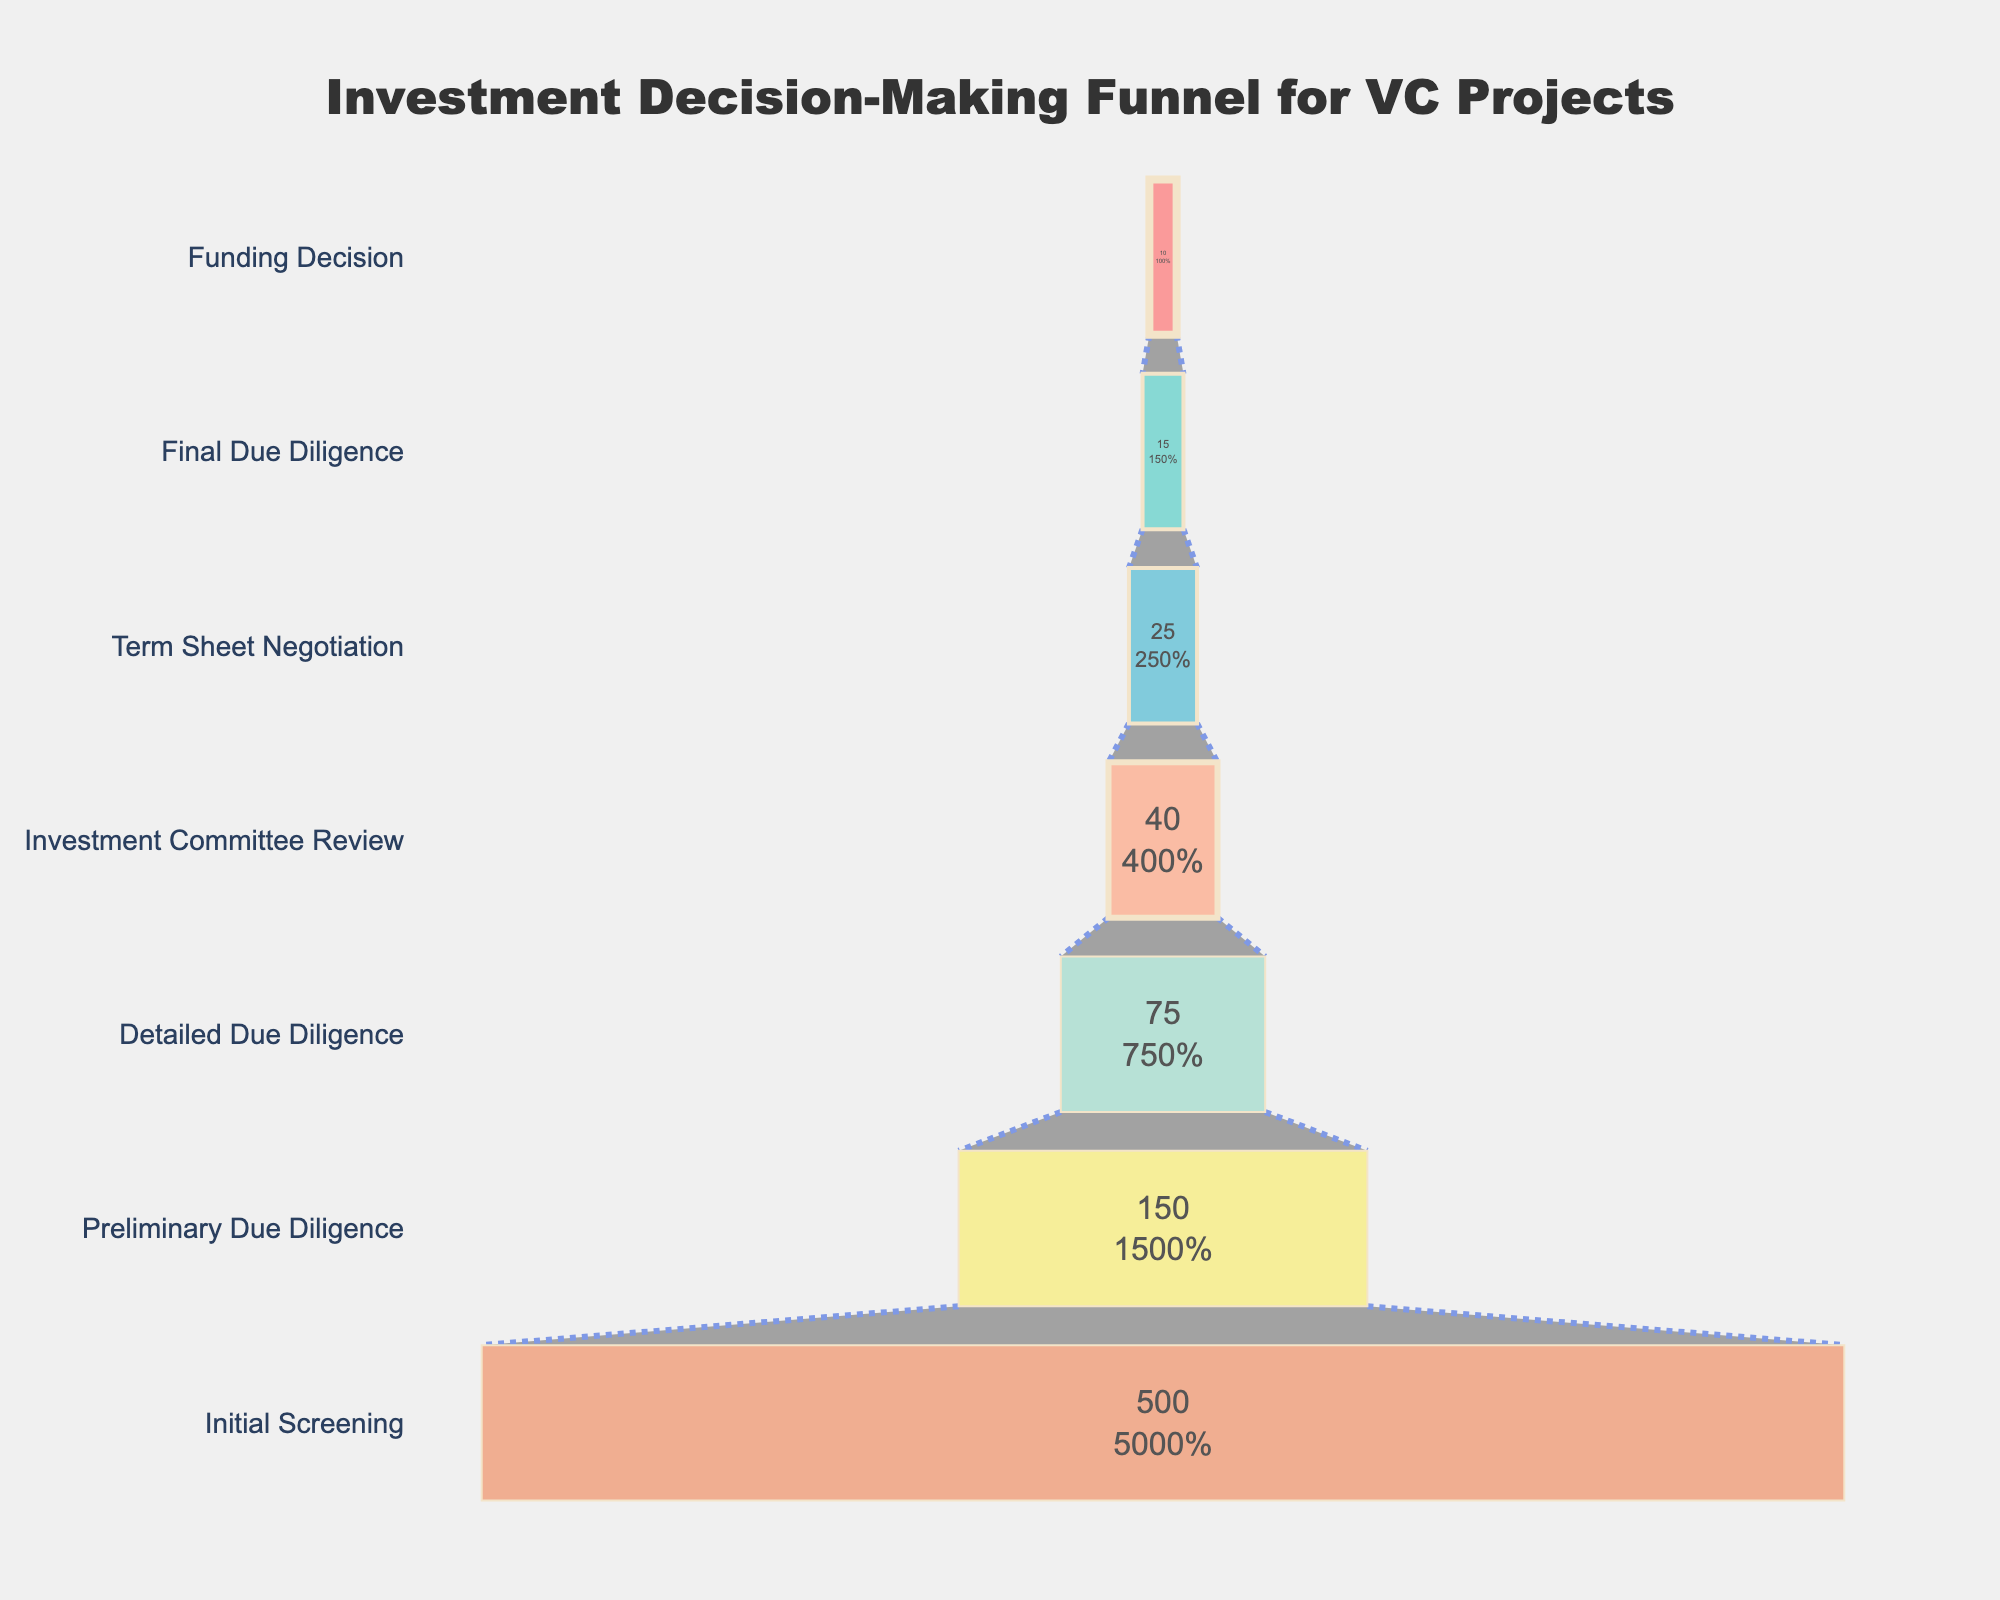What is the title of the funnel chart? The title is generally located at the top of the chart. In this case, it reads "Investment Decision-Making Funnel for VC Projects".
Answer: Investment Decision-Making Funnel for VC Projects How many projects made it to the Final Due Diligence stage? Look at the section labeled "Final Due Diligence"; the associated value is 15.
Answer: 15 What percentage of projects from the Initial Screening passed to the Preliminary Due Diligence stage? The chart shows 150 out of the 500 initial projects progressed to Preliminary Due Diligence. The percentage is calculated as (150/500) * 100.
Answer: 30% What is the difference in the number of projects between the Preliminary Due Diligence and Investment Committee Review stages? The value for Preliminary Due Diligence is 150 and for Investment Committee Review is 40. Subtract 40 from 150.
Answer: 110 Which stage has the fewest projects? Look for the stage with the smallest number; this is "Funding Decision" with 10 projects.
Answer: Funding Decision Between which two stages is the greatest reduction in the number of projects observed? Compare the reduction between consecutive stages. The largest drop is from Initial Screening to Preliminary Due Diligence (from 500 to 150), which is a reduction of 350 projects.
Answer: Initial Screening to Preliminary Due Diligence What is the average number of projects across all stages? Sum the number of projects at all stages and divide by the number of stages. The sum is (500 + 150 + 75 + 40 + 25 + 15 + 10) = 815, and there are 7 stages. The average is 815/7.
Answer: 116.43 How many stages are displayed in the funnel chart? Count the number of distinct stages listed on the y-axis of the funnel chart.
Answer: 7 Explain the color coding used in the funnel chart. Colors differentiate between stages. Each stage has a unique color which helps visually distinguish each part of the funnel. For instance, Initial Screening is colored in red (#FF6B6B), Preliminary Due Diligence in green (#4ECDC4), and so forth.
Answer: Each stage has a unique color If the number of projects in Term Sheet Negotiation doubled, how many would there be? The current number of projects in Term Sheet Negotiation is 25. Doubling this, you calculate 25 * 2.
Answer: 50 